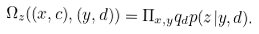<formula> <loc_0><loc_0><loc_500><loc_500>\Omega _ { z } ( ( x , c ) , ( y , d ) ) = \Pi _ { x , y } q _ { d } p ( z | y , d ) .</formula> 